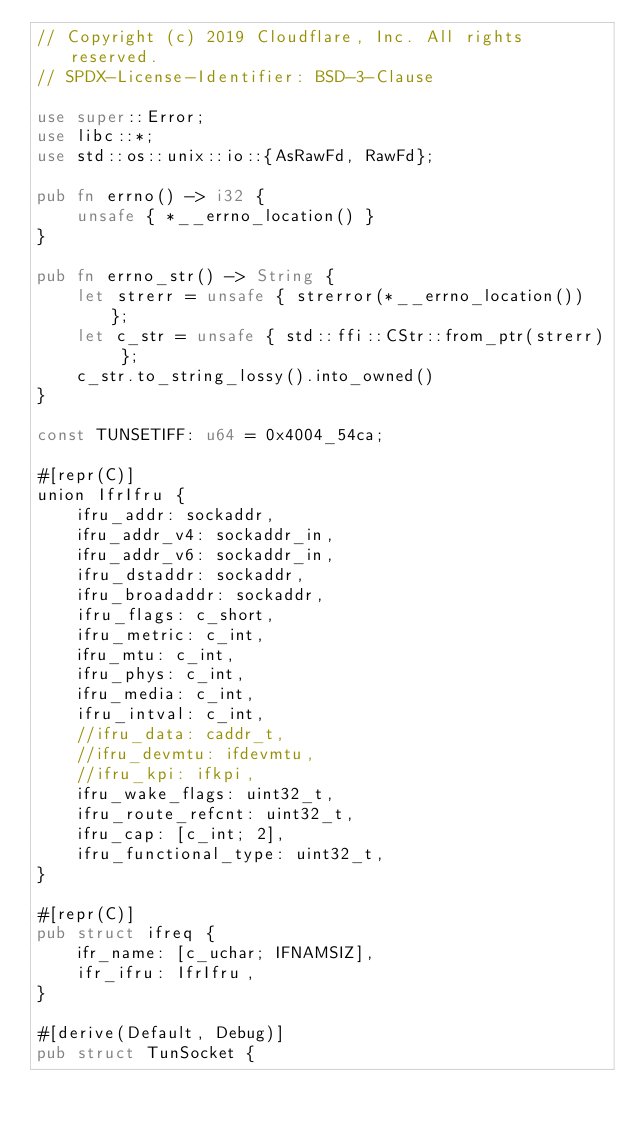<code> <loc_0><loc_0><loc_500><loc_500><_Rust_>// Copyright (c) 2019 Cloudflare, Inc. All rights reserved.
// SPDX-License-Identifier: BSD-3-Clause

use super::Error;
use libc::*;
use std::os::unix::io::{AsRawFd, RawFd};

pub fn errno() -> i32 {
    unsafe { *__errno_location() }
}

pub fn errno_str() -> String {
    let strerr = unsafe { strerror(*__errno_location()) };
    let c_str = unsafe { std::ffi::CStr::from_ptr(strerr) };
    c_str.to_string_lossy().into_owned()
}

const TUNSETIFF: u64 = 0x4004_54ca;

#[repr(C)]
union IfrIfru {
    ifru_addr: sockaddr,
    ifru_addr_v4: sockaddr_in,
    ifru_addr_v6: sockaddr_in,
    ifru_dstaddr: sockaddr,
    ifru_broadaddr: sockaddr,
    ifru_flags: c_short,
    ifru_metric: c_int,
    ifru_mtu: c_int,
    ifru_phys: c_int,
    ifru_media: c_int,
    ifru_intval: c_int,
    //ifru_data: caddr_t,
    //ifru_devmtu: ifdevmtu,
    //ifru_kpi: ifkpi,
    ifru_wake_flags: uint32_t,
    ifru_route_refcnt: uint32_t,
    ifru_cap: [c_int; 2],
    ifru_functional_type: uint32_t,
}

#[repr(C)]
pub struct ifreq {
    ifr_name: [c_uchar; IFNAMSIZ],
    ifr_ifru: IfrIfru,
}

#[derive(Default, Debug)]
pub struct TunSocket {</code> 